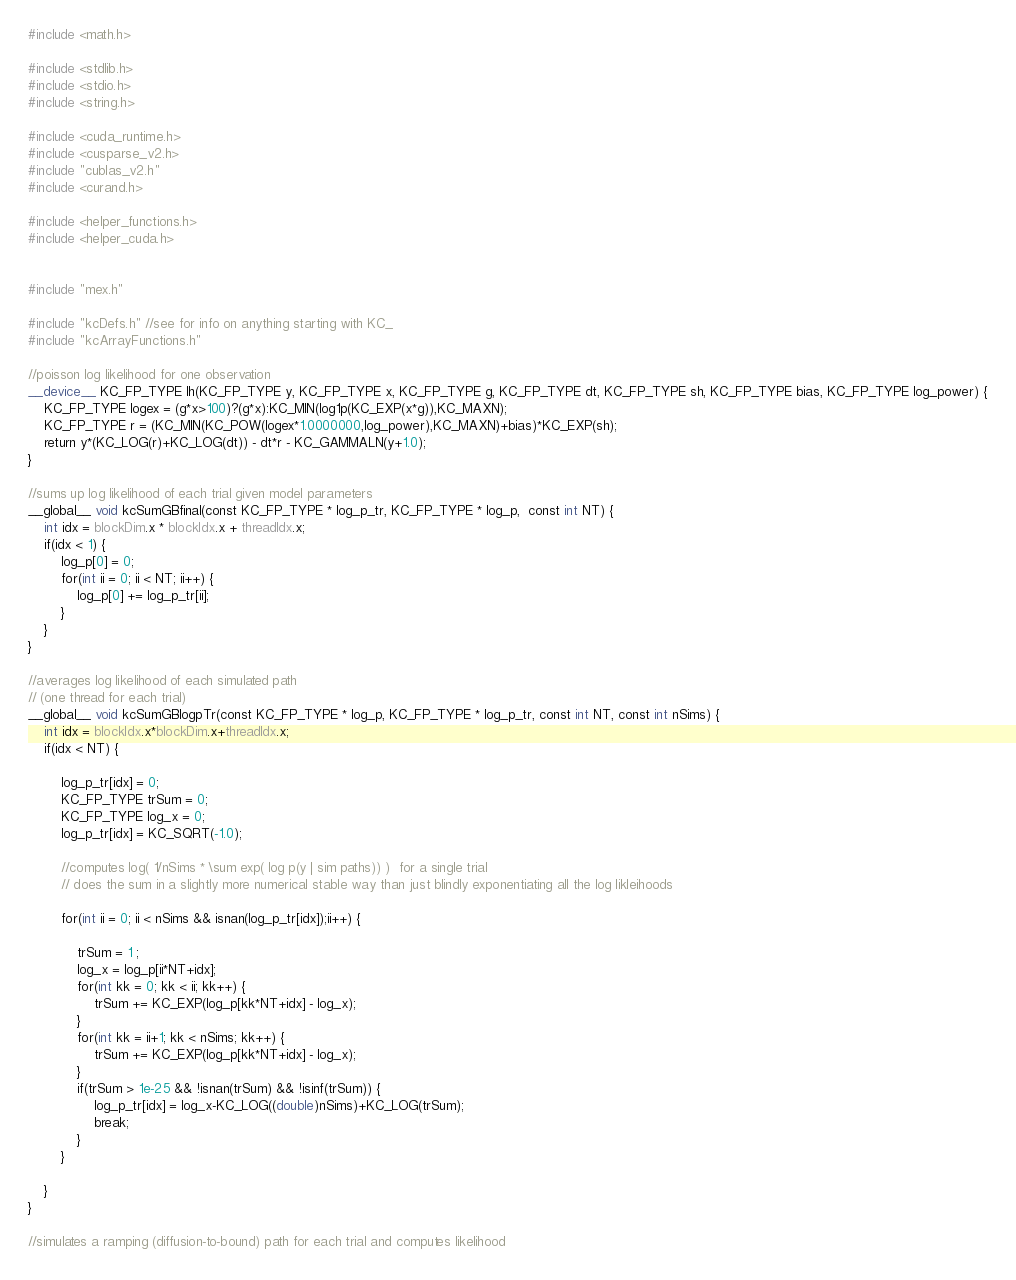Convert code to text. <code><loc_0><loc_0><loc_500><loc_500><_Cuda_>#include <math.h>

#include <stdlib.h>
#include <stdio.h>
#include <string.h>

#include <cuda_runtime.h>
#include <cusparse_v2.h>
#include "cublas_v2.h"
#include <curand.h>

#include <helper_functions.h>
#include <helper_cuda.h>


#include "mex.h"

#include "kcDefs.h" //see for info on anything starting with KC_
#include "kcArrayFunctions.h"

//poisson log likelihood for one observation
__device__ KC_FP_TYPE lh(KC_FP_TYPE y, KC_FP_TYPE x, KC_FP_TYPE g, KC_FP_TYPE dt, KC_FP_TYPE sh, KC_FP_TYPE bias, KC_FP_TYPE log_power) {
    KC_FP_TYPE logex = (g*x>100)?(g*x):KC_MIN(log1p(KC_EXP(x*g)),KC_MAXN);
    KC_FP_TYPE r = (KC_MIN(KC_POW(logex*1.0000000,log_power),KC_MAXN)+bias)*KC_EXP(sh);
    return y*(KC_LOG(r)+KC_LOG(dt)) - dt*r - KC_GAMMALN(y+1.0);
}

//sums up log likelihood of each trial given model parameters
__global__ void kcSumGBfinal(const KC_FP_TYPE * log_p_tr, KC_FP_TYPE * log_p,  const int NT) {
    int idx = blockDim.x * blockIdx.x + threadIdx.x;
    if(idx < 1) {
        log_p[0] = 0;
        for(int ii = 0; ii < NT; ii++) {
            log_p[0] += log_p_tr[ii];
        }
    }
}

//averages log likelihood of each simulated path
// (one thread for each trial)
__global__ void kcSumGBlogpTr(const KC_FP_TYPE * log_p, KC_FP_TYPE * log_p_tr, const int NT, const int nSims) {
    int idx = blockIdx.x*blockDim.x+threadIdx.x;
    if(idx < NT) {
        
        log_p_tr[idx] = 0;
        KC_FP_TYPE trSum = 0;
        KC_FP_TYPE log_x = 0;
        log_p_tr[idx] = KC_SQRT(-1.0);
        
        //computes log( 1/nSims * \sum exp( log p(y | sim paths)) )  for a single trial
        // does the sum in a slightly more numerical stable way than just blindly exponentiating all the log likleihoods
        
        for(int ii = 0; ii < nSims && isnan(log_p_tr[idx]);ii++) {

            trSum = 1 ;
            log_x = log_p[ii*NT+idx];
            for(int kk = 0; kk < ii; kk++) {
                trSum += KC_EXP(log_p[kk*NT+idx] - log_x);
            }
            for(int kk = ii+1; kk < nSims; kk++) {
                trSum += KC_EXP(log_p[kk*NT+idx] - log_x);
            }
            if(trSum > 1e-25 && !isnan(trSum) && !isinf(trSum)) {
                log_p_tr[idx] = log_x-KC_LOG((double)nSims)+KC_LOG(trSum);
                break;
            }
        }
        
    }
}

//simulates a ramping (diffusion-to-bound) path for each trial and computes likelihood</code> 